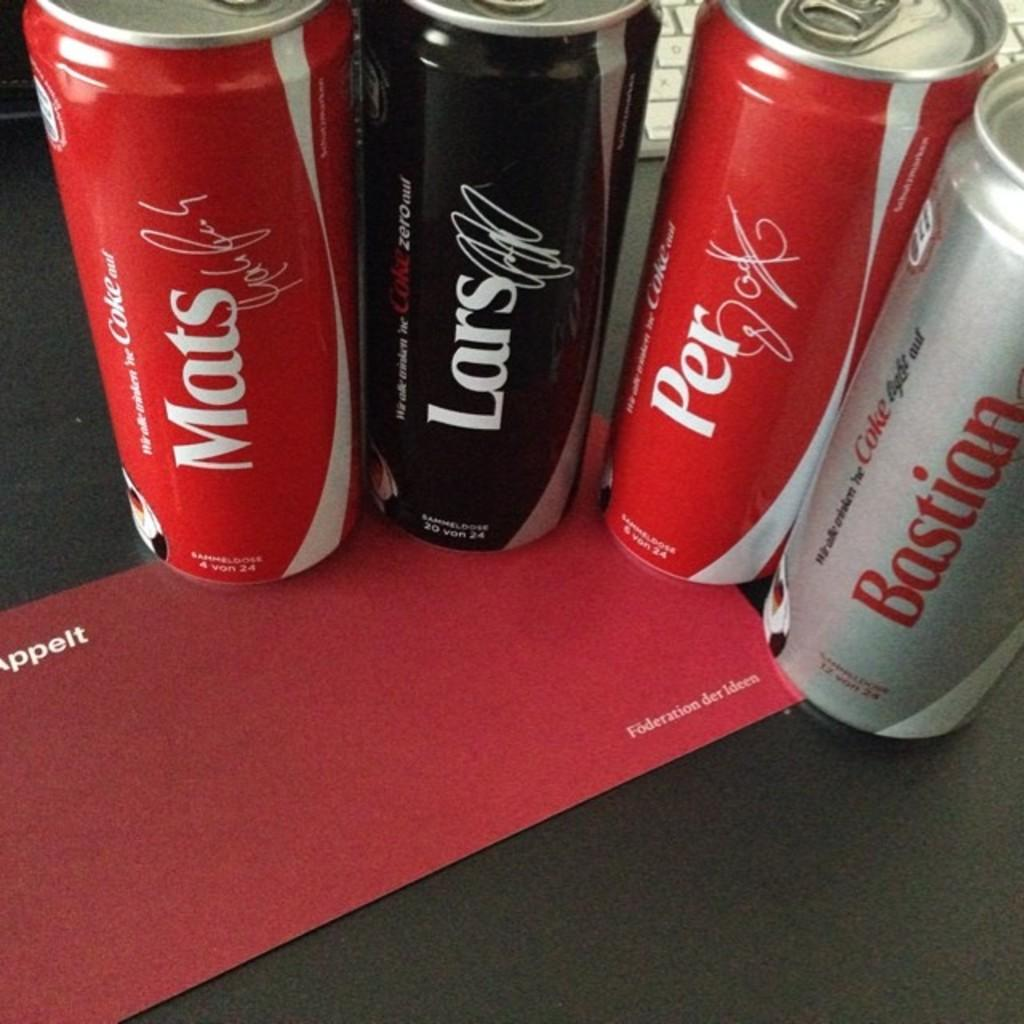<image>
Give a short and clear explanation of the subsequent image. Four different Coke cans on a row with one saying Bastian. 